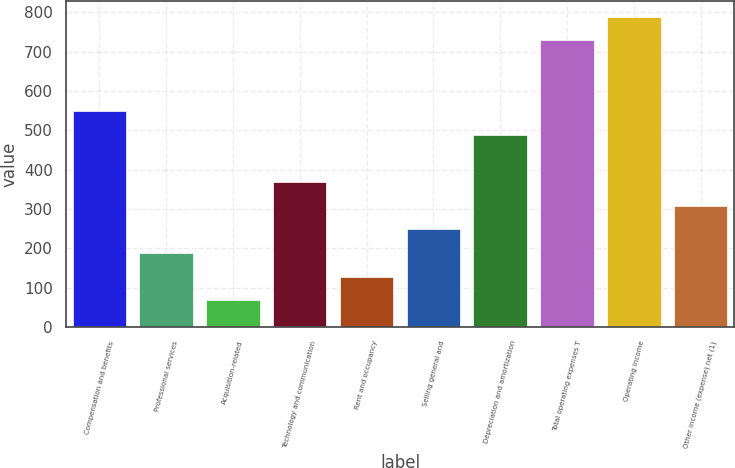Convert chart to OTSL. <chart><loc_0><loc_0><loc_500><loc_500><bar_chart><fcel>Compensation and benefits<fcel>Professional services<fcel>Acquisition-related<fcel>Technology and communication<fcel>Rent and occupancy<fcel>Selling general and<fcel>Depreciation and amortization<fcel>Total operating expenses T<fcel>Operating income<fcel>Other income (expense) net (1)<nl><fcel>548.9<fcel>188.3<fcel>68.1<fcel>368.6<fcel>128.2<fcel>248.4<fcel>488.8<fcel>729.2<fcel>789.3<fcel>308.5<nl></chart> 